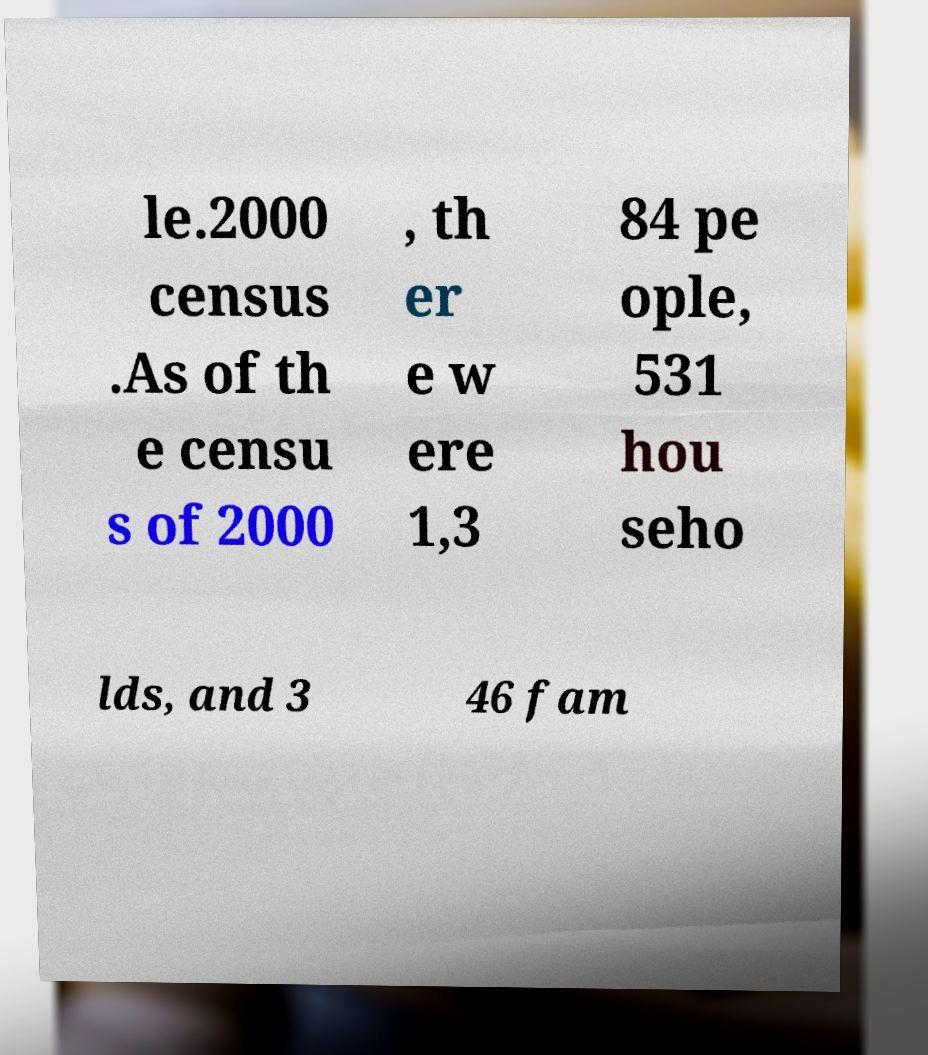Can you accurately transcribe the text from the provided image for me? le.2000 census .As of th e censu s of 2000 , th er e w ere 1,3 84 pe ople, 531 hou seho lds, and 3 46 fam 